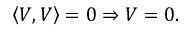<formula> <loc_0><loc_0><loc_500><loc_500>\left \langle V , V \right \rangle = 0 \Rightarrow V = 0 .</formula> 